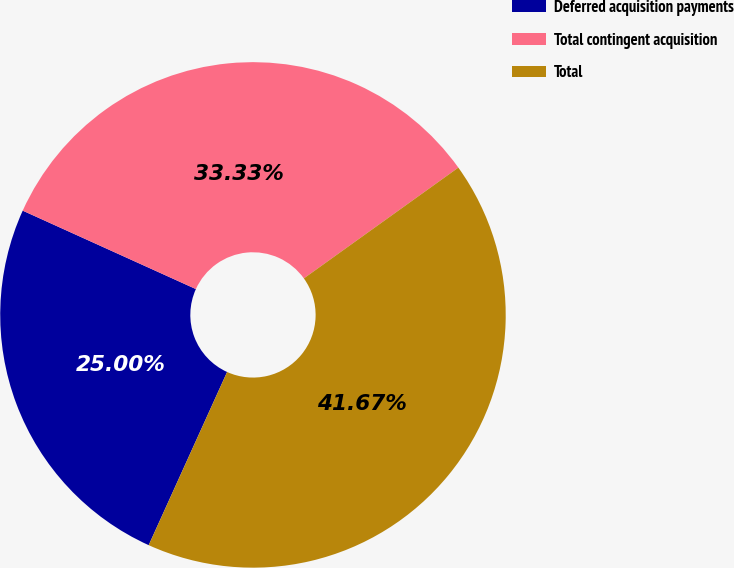Convert chart to OTSL. <chart><loc_0><loc_0><loc_500><loc_500><pie_chart><fcel>Deferred acquisition payments<fcel>Total contingent acquisition<fcel>Total<nl><fcel>25.0%<fcel>33.33%<fcel>41.67%<nl></chart> 